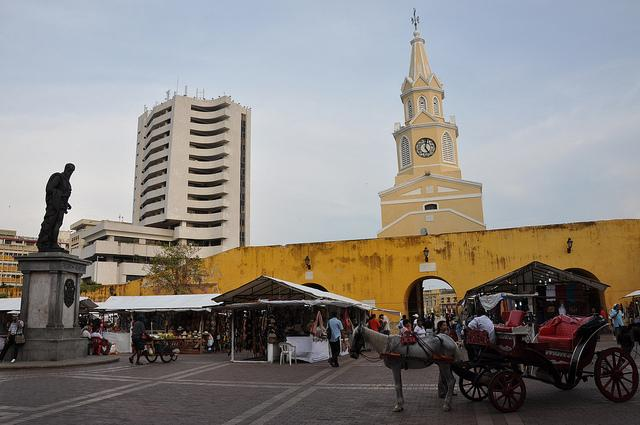Which structure was put up most recently? Please explain your reasoning. tent. A tent was likely put up most recently. 